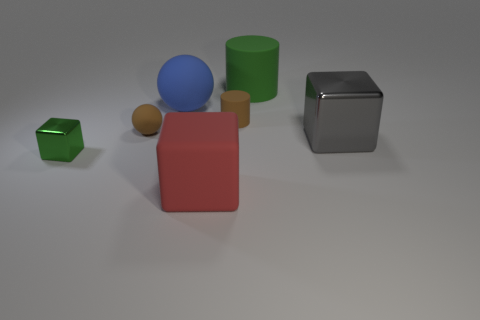Subtract all metallic cubes. How many cubes are left? 1 Subtract all green cubes. How many cubes are left? 2 Add 2 brown matte things. How many objects exist? 9 Subtract 2 cubes. How many cubes are left? 1 Subtract all cubes. How many objects are left? 4 Subtract all yellow spheres. Subtract all purple cubes. How many spheres are left? 2 Subtract all red balls. How many gray cubes are left? 1 Subtract all large red blocks. Subtract all green blocks. How many objects are left? 5 Add 6 gray objects. How many gray objects are left? 7 Add 3 big gray objects. How many big gray objects exist? 4 